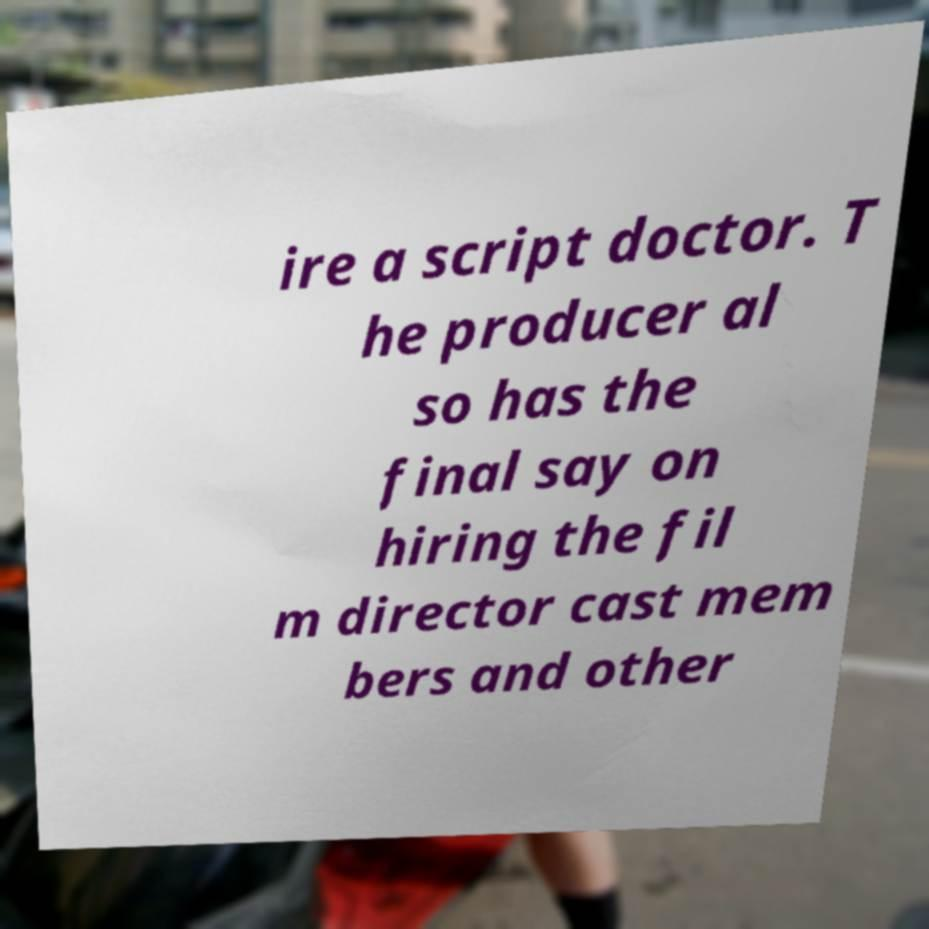For documentation purposes, I need the text within this image transcribed. Could you provide that? ire a script doctor. T he producer al so has the final say on hiring the fil m director cast mem bers and other 